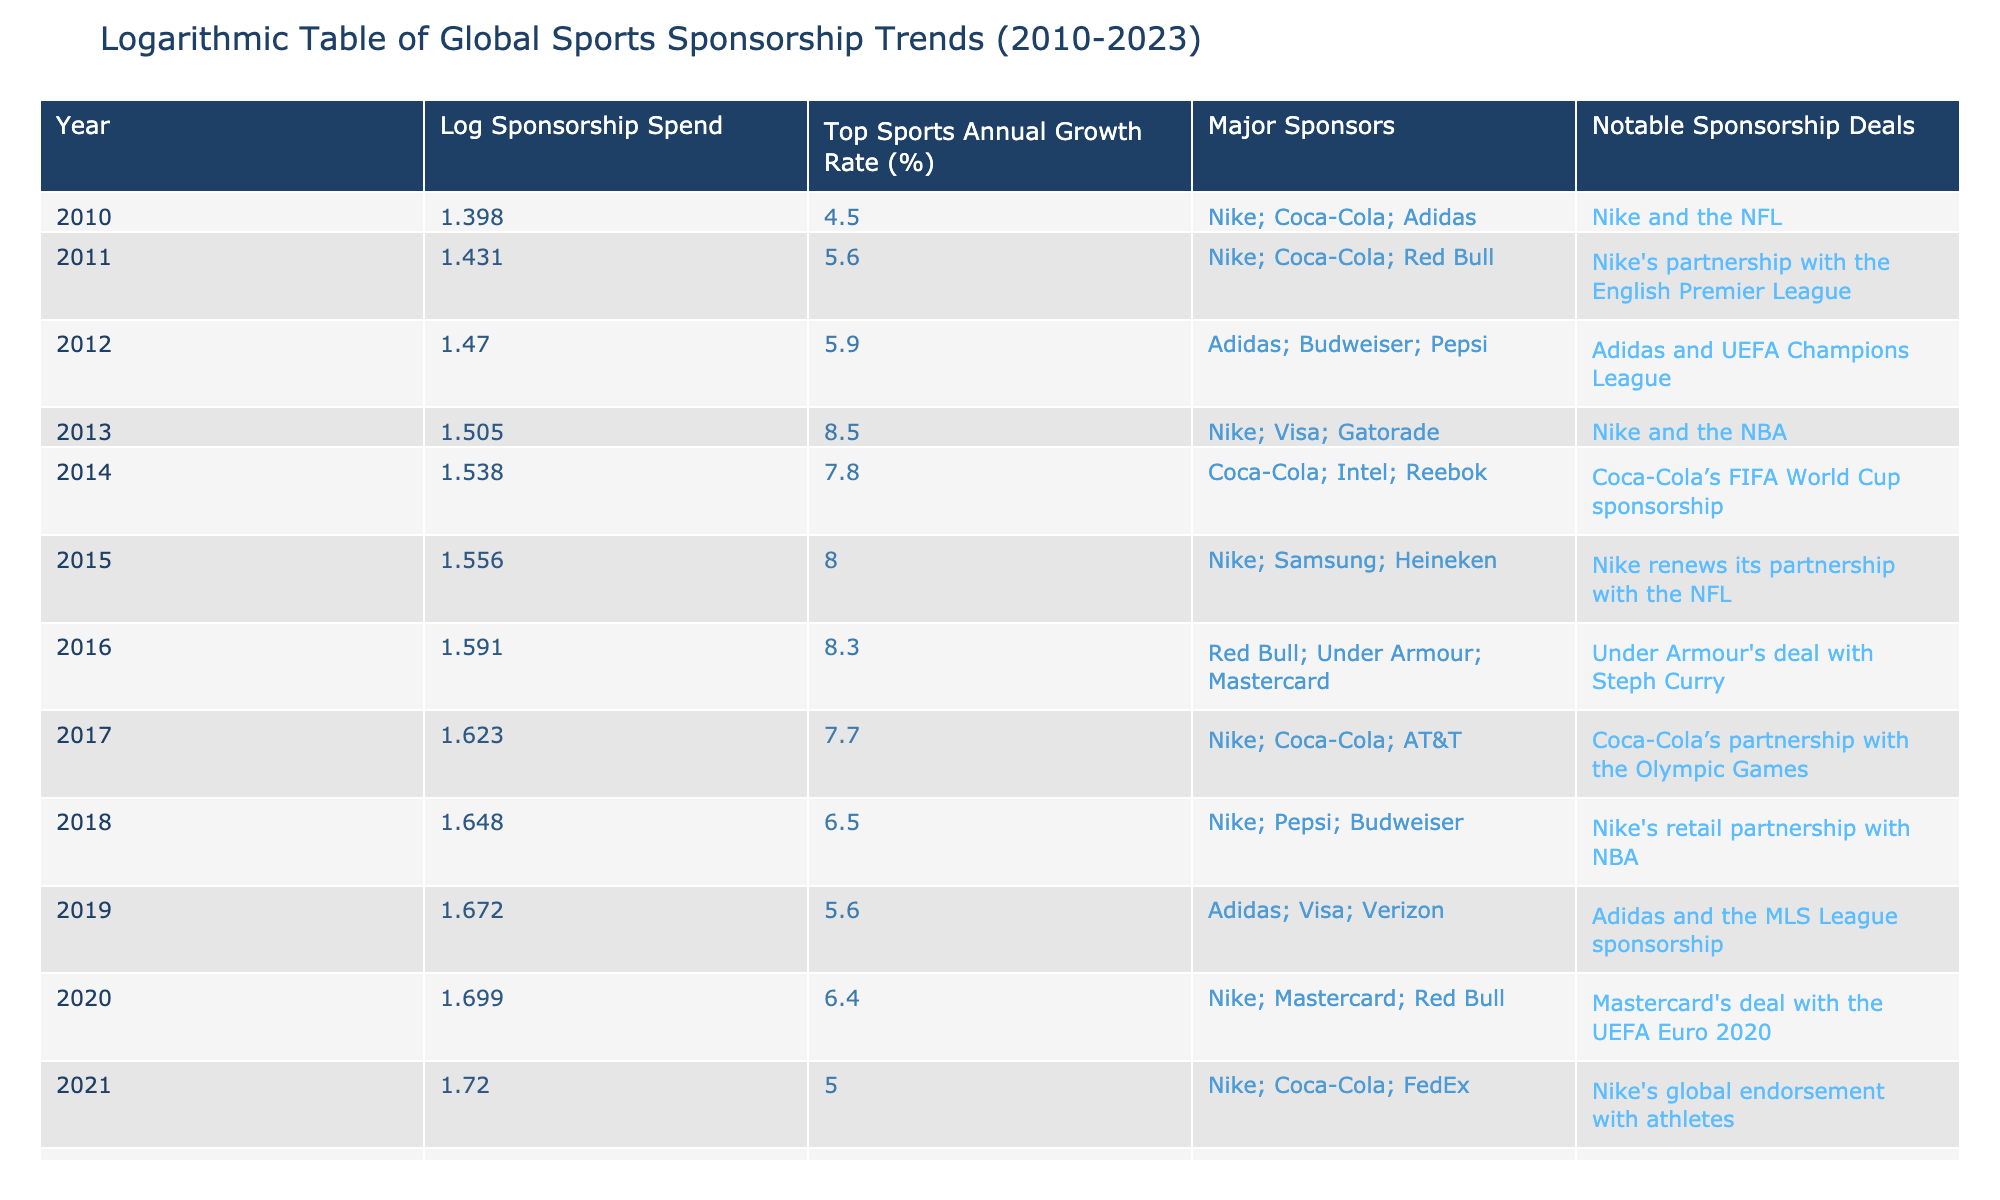What was the global sports sponsorship spend in 2015? According to the table, the global sports sponsorship spend in 2015 is listed as 36.0 billion USD.
Answer: 36.0 billion USD What is the top sports annual growth rate in 2013? The entry for 2013 shows a top sports annual growth rate of 8.5%.
Answer: 8.5% Which year had the highest global sports sponsorship spend value? By reviewing the data, the year 2023 has the highest global sports sponsorship spend at 58.0 billion USD.
Answer: 2023 What was the increase in global sports sponsorship spend from 2010 to 2020? The spend in 2010 was 25.0 billion USD and in 2020 it was 50.0 billion USD. The increase is 50.0 - 25.0 = 25.0 billion USD.
Answer: 25.0 billion USD Did Coca-Cola sponsor any events in both 2014 and 2017? Yes, Coca-Cola is listed as a major sponsor in both 2014 and 2017, indicating their continued involvement in sports sponsorship during those years.
Answer: Yes What was the average top sports annual growth rate from 2010 to 2023? To find the average, the total growth rates must be summed: (4.5 + 5.6 + 5.9 + 8.5 + 7.8 + 8.0 + 8.3 + 7.7 + 6.5 + 5.6 + 6.4 + 5.0 + 4.8 + 5.5) / 14 = 6.15%.
Answer: 6.15% Which notable sponsorship deal occurred in 2012? The notable sponsorship deal in 2012 was Adidas and UEFA Champions League, as indicated in the table for that year.
Answer: Adidas and UEFA Champions League What percentage change in the global sports sponsorship spend occurred from 2011 to 2012? The spend in 2011 was 27.0 billion USD and in 2012 it was 29.5 billion USD. The change is (29.5 - 27.0) / 27.0 * 100 = 9.26%.
Answer: 9.26% 